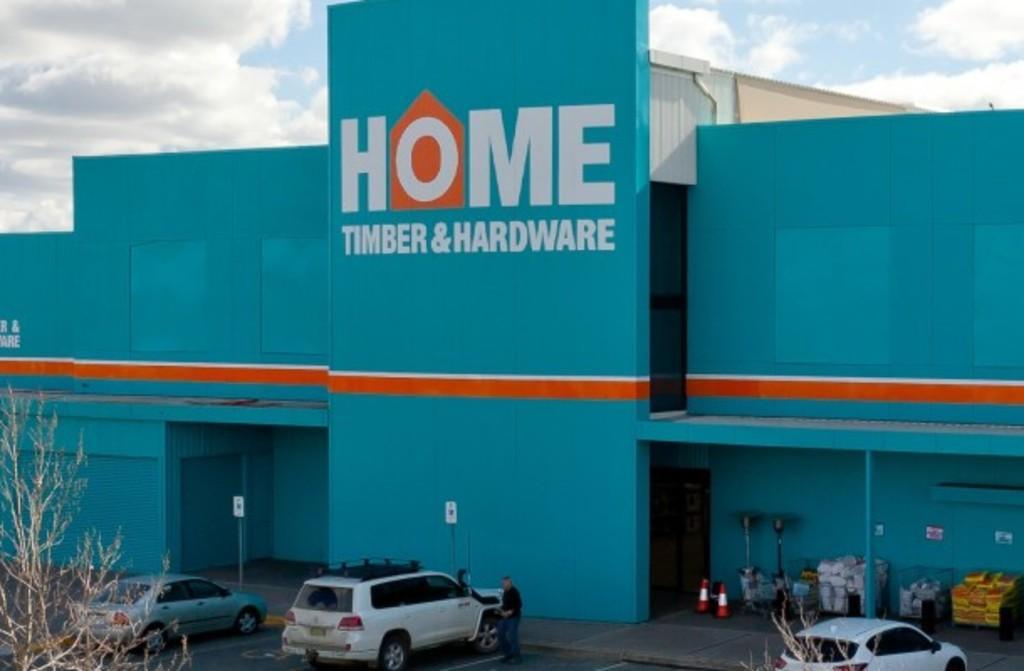In one or two sentences, can you explain what this image depicts? In this image there is a building with a name written on it, there are vehicles and a person on the road, there are few signboard, diversion cones, few objects in the trays, some posters attached to the wall and some clouds in the sky. 